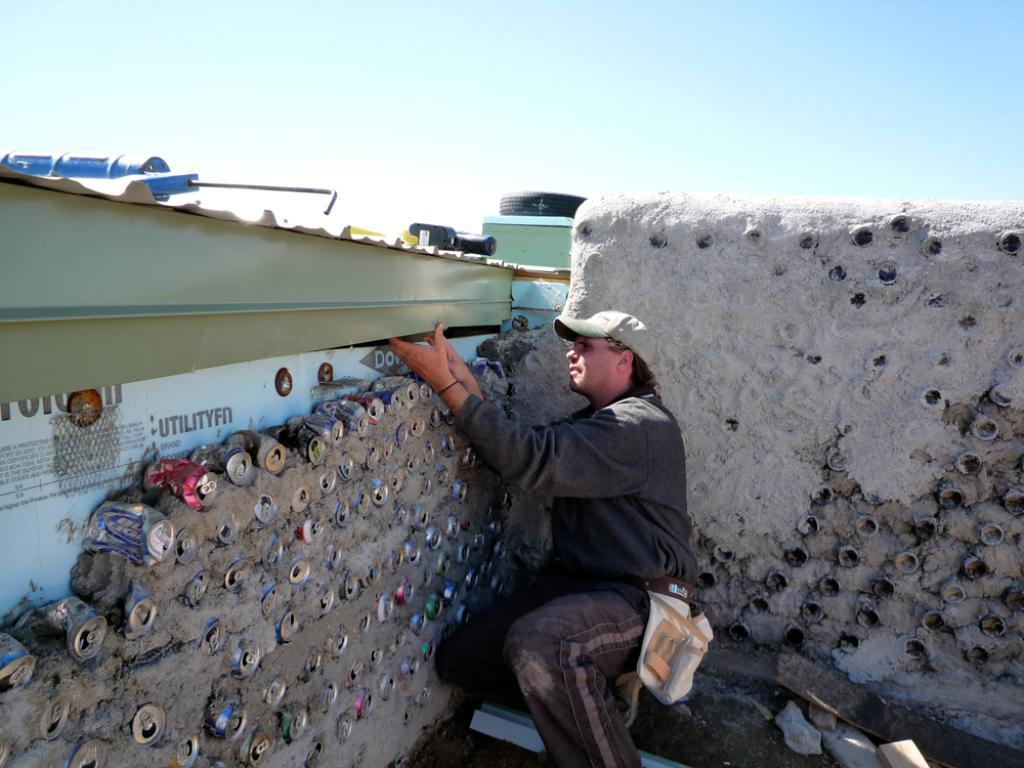<image>
Render a clear and concise summary of the photo. A man is working near a wall that has the word UTILITYFN on it. 